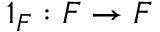<formula> <loc_0><loc_0><loc_500><loc_500>1 _ { F } \colon F \to F</formula> 